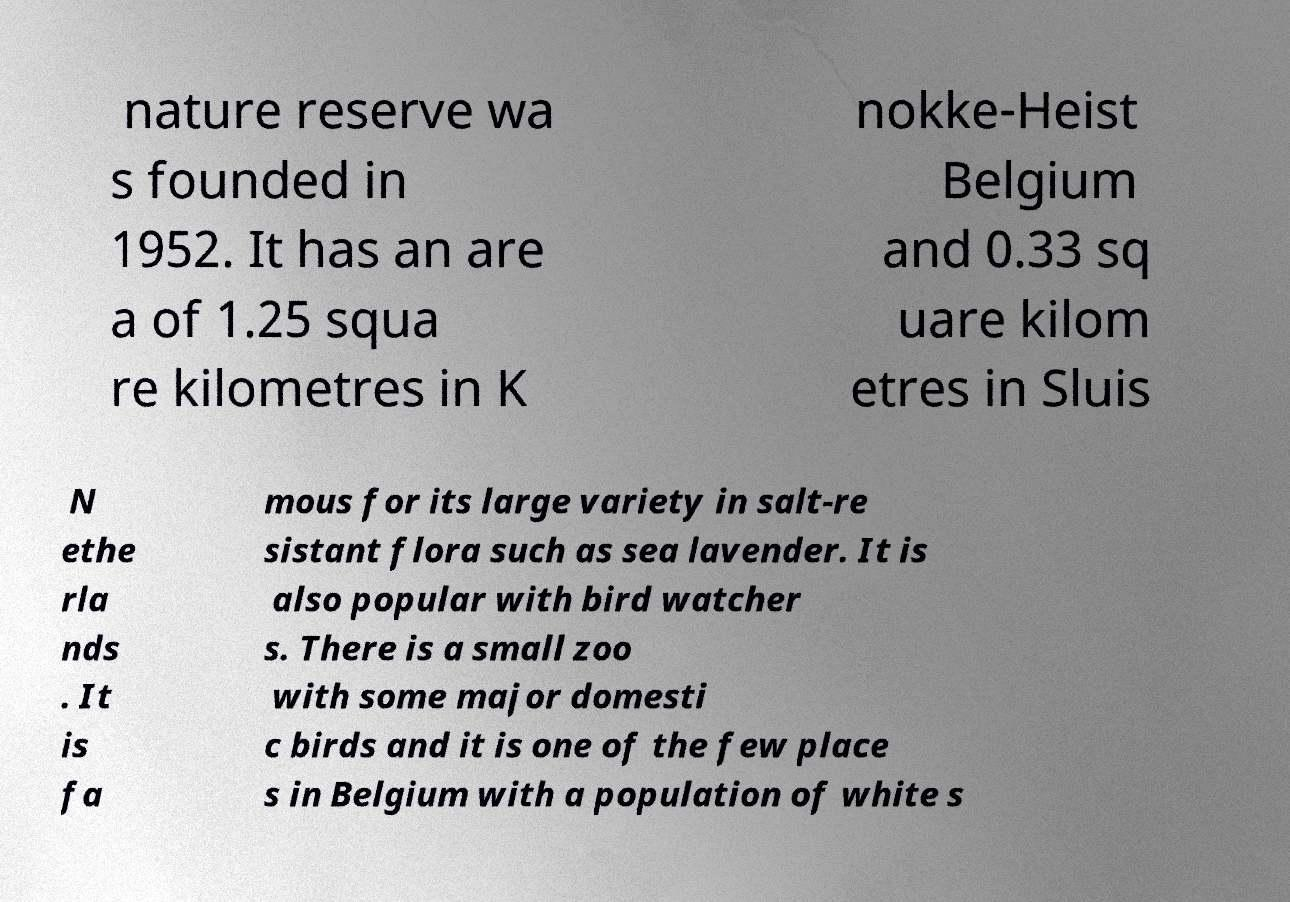Can you read and provide the text displayed in the image?This photo seems to have some interesting text. Can you extract and type it out for me? nature reserve wa s founded in 1952. It has an are a of 1.25 squa re kilometres in K nokke-Heist Belgium and 0.33 sq uare kilom etres in Sluis N ethe rla nds . It is fa mous for its large variety in salt-re sistant flora such as sea lavender. It is also popular with bird watcher s. There is a small zoo with some major domesti c birds and it is one of the few place s in Belgium with a population of white s 